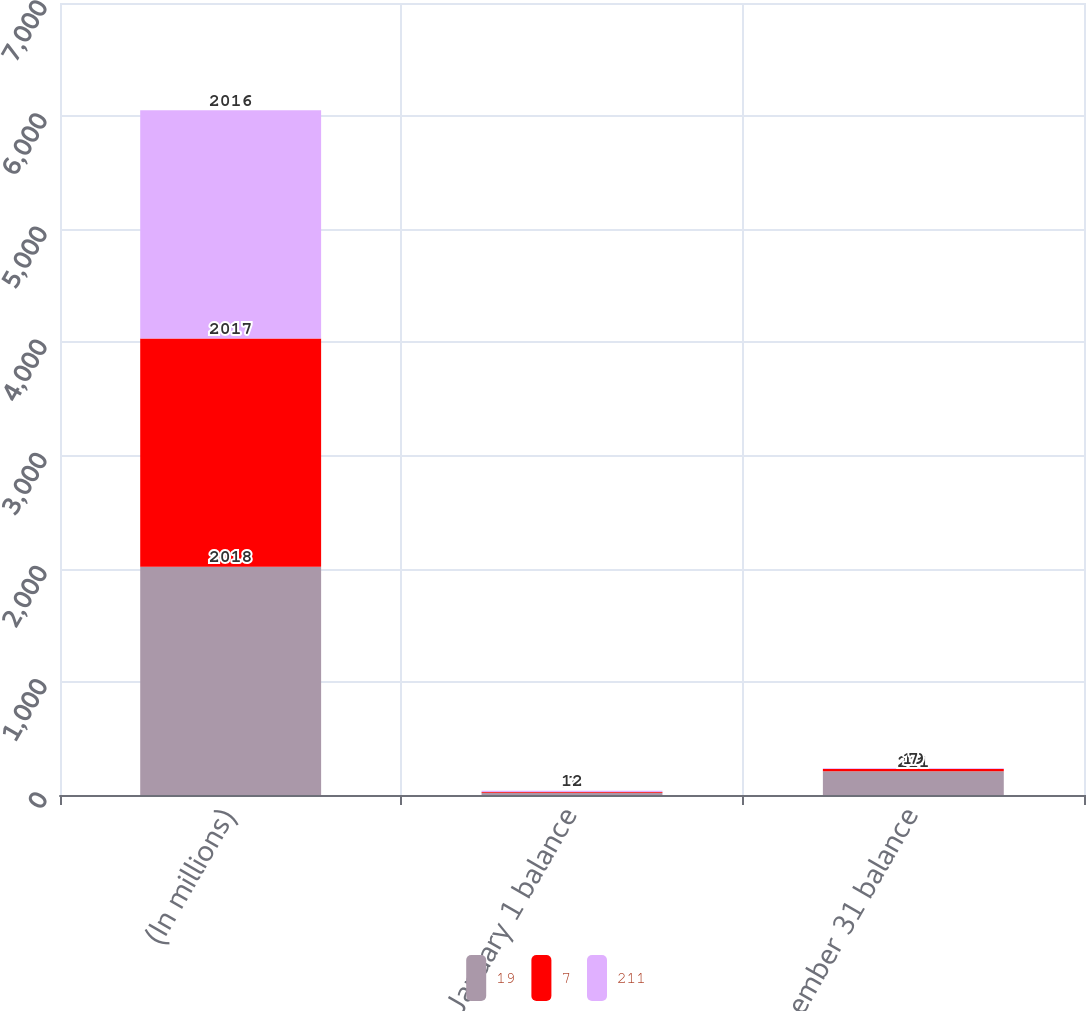Convert chart to OTSL. <chart><loc_0><loc_0><loc_500><loc_500><stacked_bar_chart><ecel><fcel>(In millions)<fcel>January 1 balance<fcel>December 31 balance<nl><fcel>19<fcel>2018<fcel>19<fcel>211<nl><fcel>7<fcel>2017<fcel>7<fcel>19<nl><fcel>211<fcel>2016<fcel>12<fcel>7<nl></chart> 